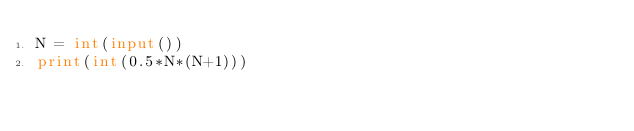<code> <loc_0><loc_0><loc_500><loc_500><_Python_>N = int(input())
print(int(0.5*N*(N+1)))</code> 